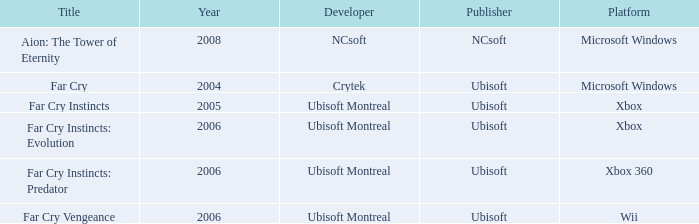Which title has a pre-2008 year and features xbox 360 as the platform? Far Cry Instincts: Predator. 